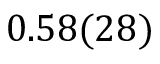Convert formula to latex. <formula><loc_0><loc_0><loc_500><loc_500>0 . 5 8 ( 2 8 )</formula> 